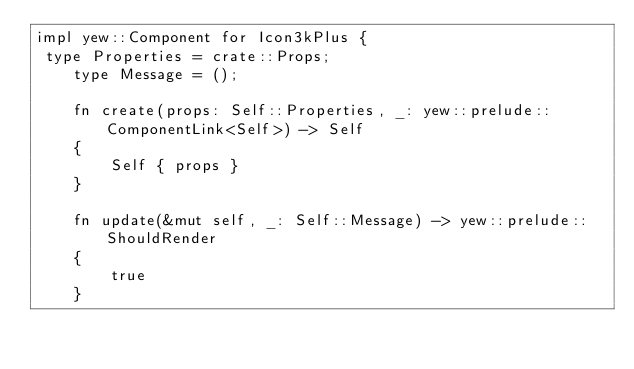<code> <loc_0><loc_0><loc_500><loc_500><_Rust_>impl yew::Component for Icon3kPlus {
 type Properties = crate::Props;
    type Message = ();

    fn create(props: Self::Properties, _: yew::prelude::ComponentLink<Self>) -> Self
    {
        Self { props }
    }

    fn update(&mut self, _: Self::Message) -> yew::prelude::ShouldRender
    {
        true
    }
</code> 